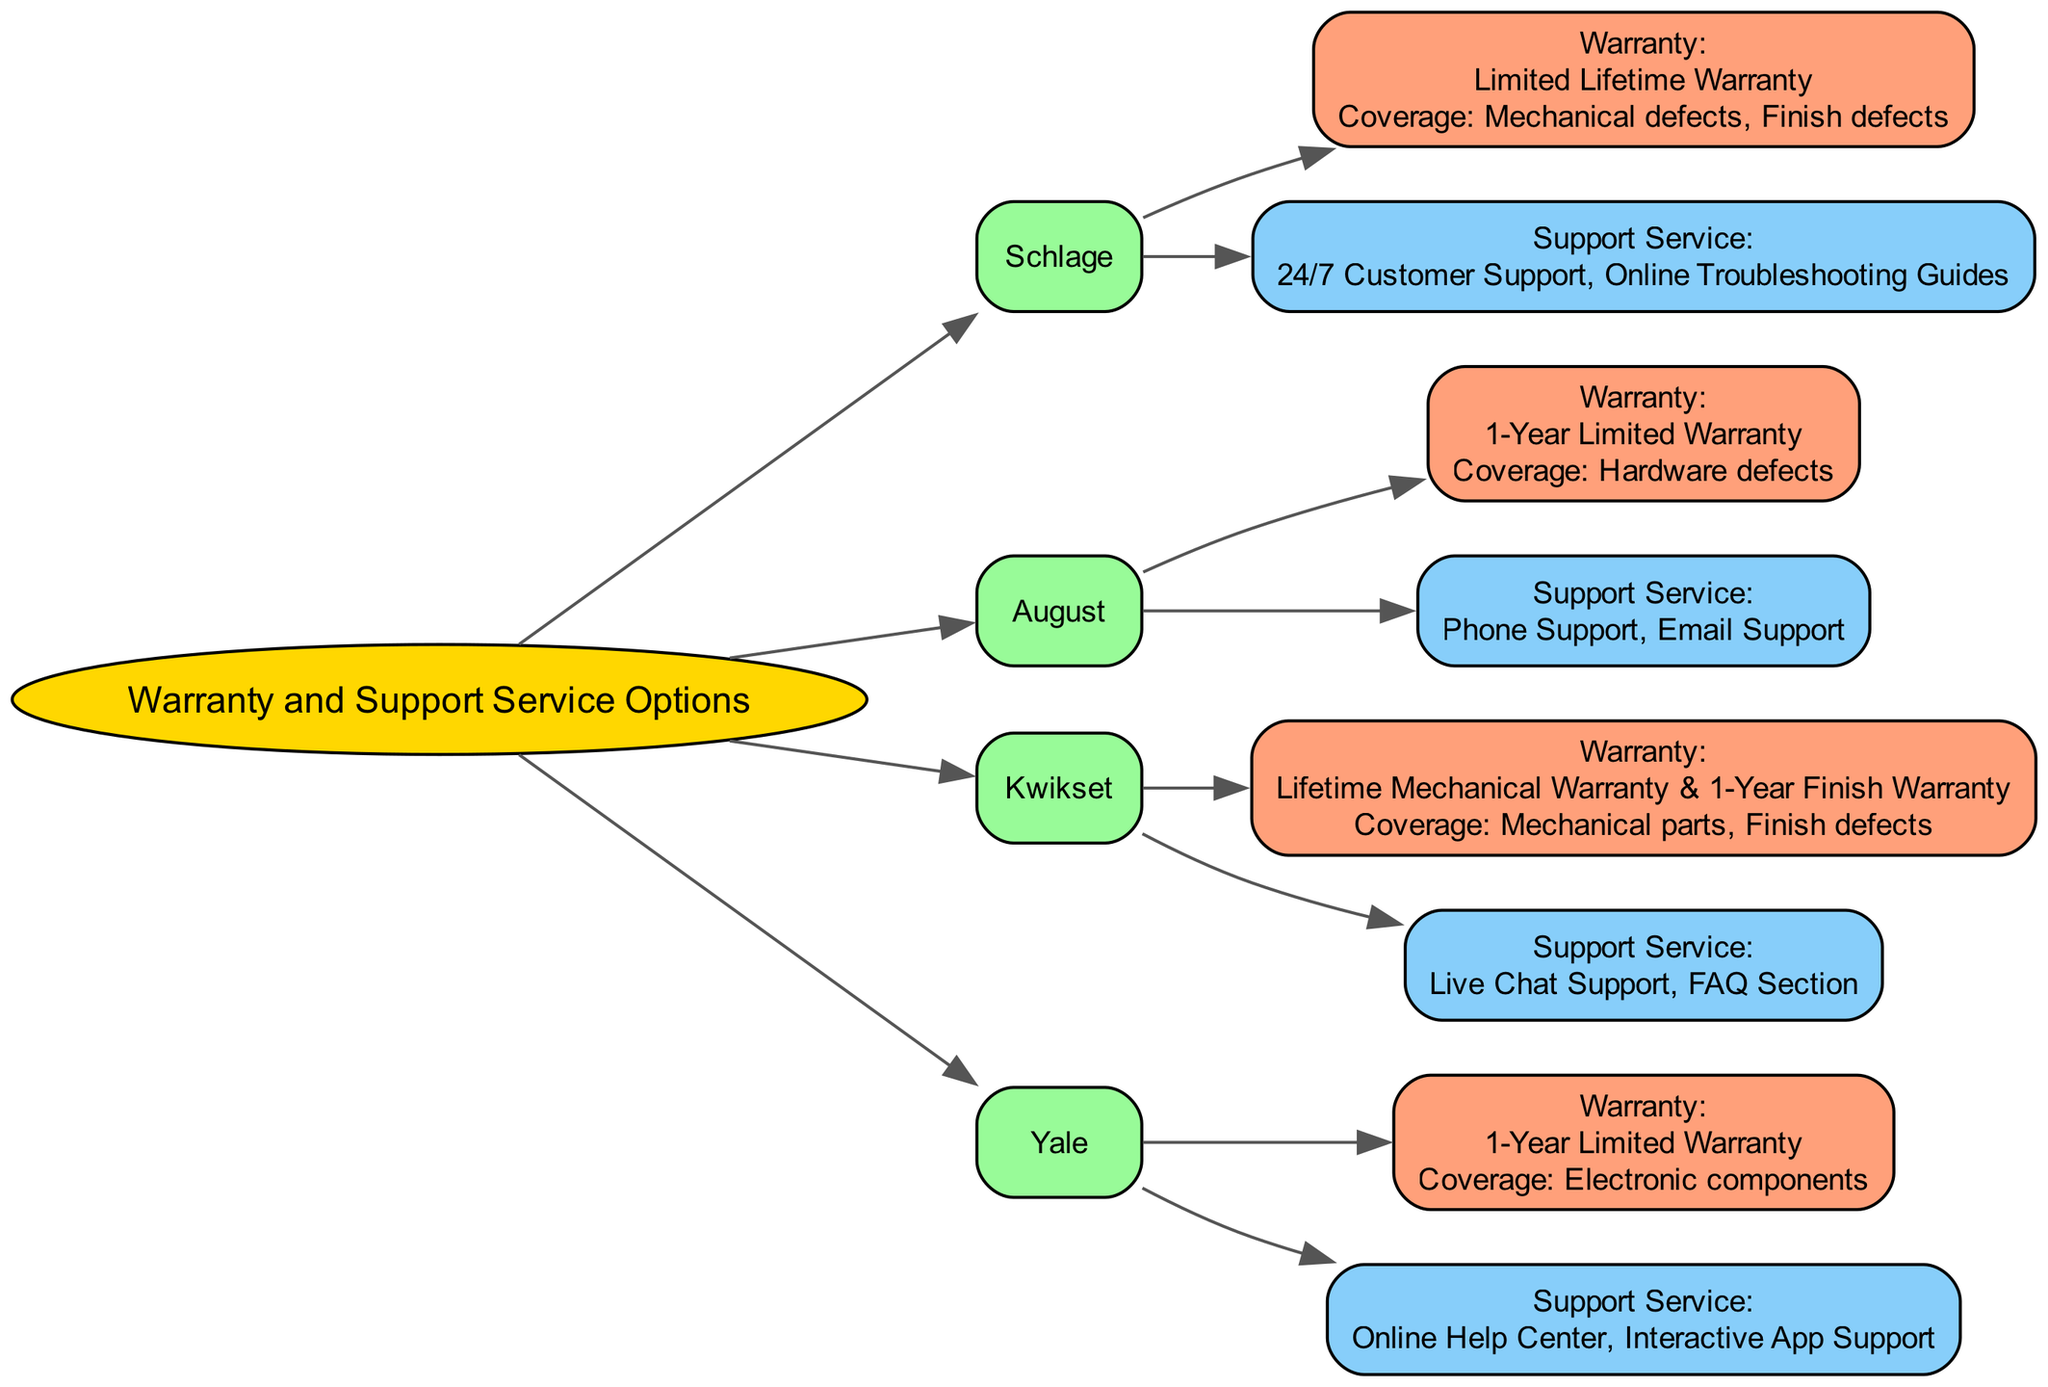What is the warranty period offered by Schlage? The diagram indicates that Schlage has a "Limited Lifetime Warranty" as its warranty period. This is visible in the warranty section connected to the Schlage manufacturer node.
Answer: Limited Lifetime Warranty What types of support service does Kwikset provide? Looking at the Kwikset node in the diagram, it shows "Live Chat Support" and "FAQ Section" listed as its support service types. These are displayed in the support service section connected to the Kwikset manufacturer node.
Answer: Live Chat Support, FAQ Section How many manufacturers offer a 1-Year Limited Warranty? The diagram shows both August and Yale with a "1-Year Limited Warranty." By counting the manufacturer nodes where this warranty type appears, we find there are two manufacturers.
Answer: 2 Which manufacturer provides 24/7 customer support? Within the diagram, the support service section of Schlage indicates "24/7 Customer Support," making it clear that Schlage is the manufacturer that offers this support feature.
Answer: Schlage What warranty coverage is provided by Kwikset? The warranty section under the Kwikset node outlines the coverage as "Mechanical parts" and "Finish defects." These details are explicitly mentioned in the warranty node connected to the Kwikset manufacturer.
Answer: Mechanical parts, Finish defects Which company has the shortest warranty duration? The diagram presents August and Yale, both of which have a "1-Year Limited Warranty." This is the shortest duration compared to the lifetime options or limited lifetime options of other manufacturers. Therefore, both August and Yale share this distinction.
Answer: August, Yale What type of warranty does Yale offer? Looking at the Yale node in the diagram, it specifies a "1-Year Limited Warranty" for the warranty type. This information is clearly indicated in the warranty section tied to the Yale manufacturer.
Answer: 1-Year Limited Warranty How many total support service types are offered by August? The diagram highlights that August offers two types of support service: "Phone Support" and "Email Support." By examining the options listed in the August node, it is clear that there are two distinct support types available.
Answer: 2 